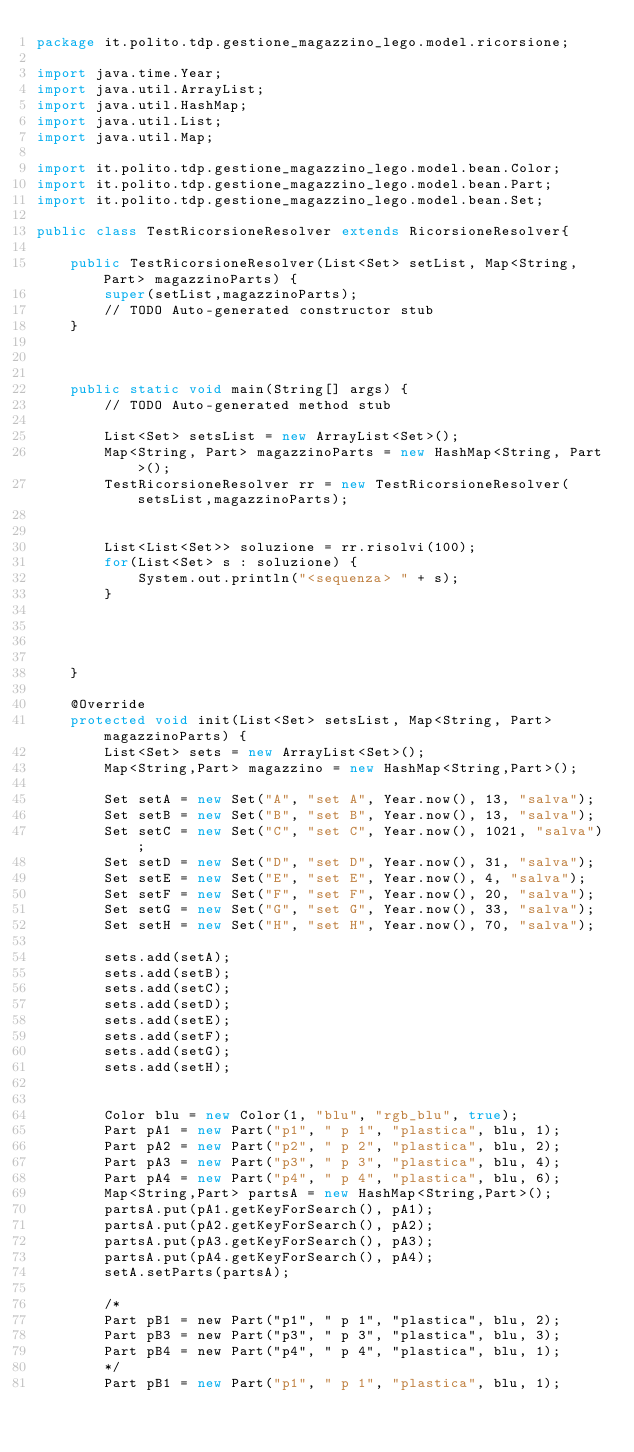<code> <loc_0><loc_0><loc_500><loc_500><_Java_>package it.polito.tdp.gestione_magazzino_lego.model.ricorsione;

import java.time.Year;
import java.util.ArrayList;
import java.util.HashMap;
import java.util.List;
import java.util.Map;

import it.polito.tdp.gestione_magazzino_lego.model.bean.Color;
import it.polito.tdp.gestione_magazzino_lego.model.bean.Part;
import it.polito.tdp.gestione_magazzino_lego.model.bean.Set;

public class TestRicorsioneResolver extends RicorsioneResolver{

	public TestRicorsioneResolver(List<Set> setList, Map<String, Part> magazzinoParts) {
		super(setList,magazzinoParts);
		// TODO Auto-generated constructor stub
	}

	
	
	public static void main(String[] args) {
		// TODO Auto-generated method stub

		List<Set> setsList = new ArrayList<Set>();
	    Map<String, Part> magazzinoParts = new HashMap<String, Part>();
		TestRicorsioneResolver rr = new TestRicorsioneResolver(setsList,magazzinoParts);
		
		
		List<List<Set>> soluzione = rr.risolvi(100);
		for(List<Set> s : soluzione) {
			System.out.println("<sequenza> " + s);
		}
		
		
				
				
	}

	@Override
	protected void init(List<Set> setsList, Map<String, Part> magazzinoParts) {
		List<Set> sets = new ArrayList<Set>();
		Map<String,Part> magazzino = new HashMap<String,Part>();

		Set setA = new Set("A", "set A", Year.now(), 13, "salva");
		Set setB = new Set("B", "set B", Year.now(), 13, "salva");
		Set setC = new Set("C", "set C", Year.now(), 1021, "salva");
		Set setD = new Set("D", "set D", Year.now(), 31, "salva");
		Set setE = new Set("E", "set E", Year.now(), 4, "salva");
		Set setF = new Set("F", "set F", Year.now(), 20, "salva");
		Set setG = new Set("G", "set G", Year.now(), 33, "salva");
		Set setH = new Set("H", "set H", Year.now(), 70, "salva");
		
		sets.add(setA);	
		sets.add(setB);	
		sets.add(setC);	
		sets.add(setD);	
		sets.add(setE);	
		sets.add(setF);	
		sets.add(setG);	
		sets.add(setH);	
		
		
		Color blu = new Color(1, "blu", "rgb_blu", true);
		Part pA1 = new Part("p1", " p 1", "plastica", blu, 1);
		Part pA2 = new Part("p2", " p 2", "plastica", blu, 2);
		Part pA3 = new Part("p3", " p 3", "plastica", blu, 4);
		Part pA4 = new Part("p4", " p 4", "plastica", blu, 6);
		Map<String,Part> partsA = new HashMap<String,Part>();
		partsA.put(pA1.getKeyForSearch(), pA1);
		partsA.put(pA2.getKeyForSearch(), pA2);
		partsA.put(pA3.getKeyForSearch(), pA3);
		partsA.put(pA4.getKeyForSearch(), pA4);
		setA.setParts(partsA);
		
		/*
		Part pB1 = new Part("p1", " p 1", "plastica", blu, 2);
		Part pB3 = new Part("p3", " p 3", "plastica", blu, 3);
		Part pB4 = new Part("p4", " p 4", "plastica", blu, 1);
		*/
		Part pB1 = new Part("p1", " p 1", "plastica", blu, 1);</code> 